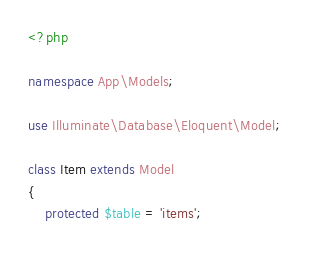<code> <loc_0><loc_0><loc_500><loc_500><_PHP_><?php

namespace App\Models;

use Illuminate\Database\Eloquent\Model;

class Item extends Model
{
    protected $table = 'items';</code> 